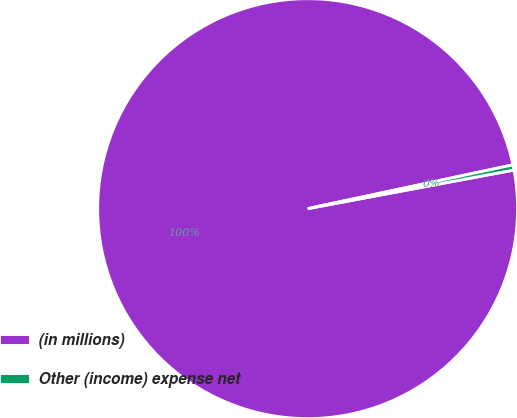Convert chart. <chart><loc_0><loc_0><loc_500><loc_500><pie_chart><fcel>(in millions)<fcel>Other (income) expense net<nl><fcel>99.6%<fcel>0.4%<nl></chart> 